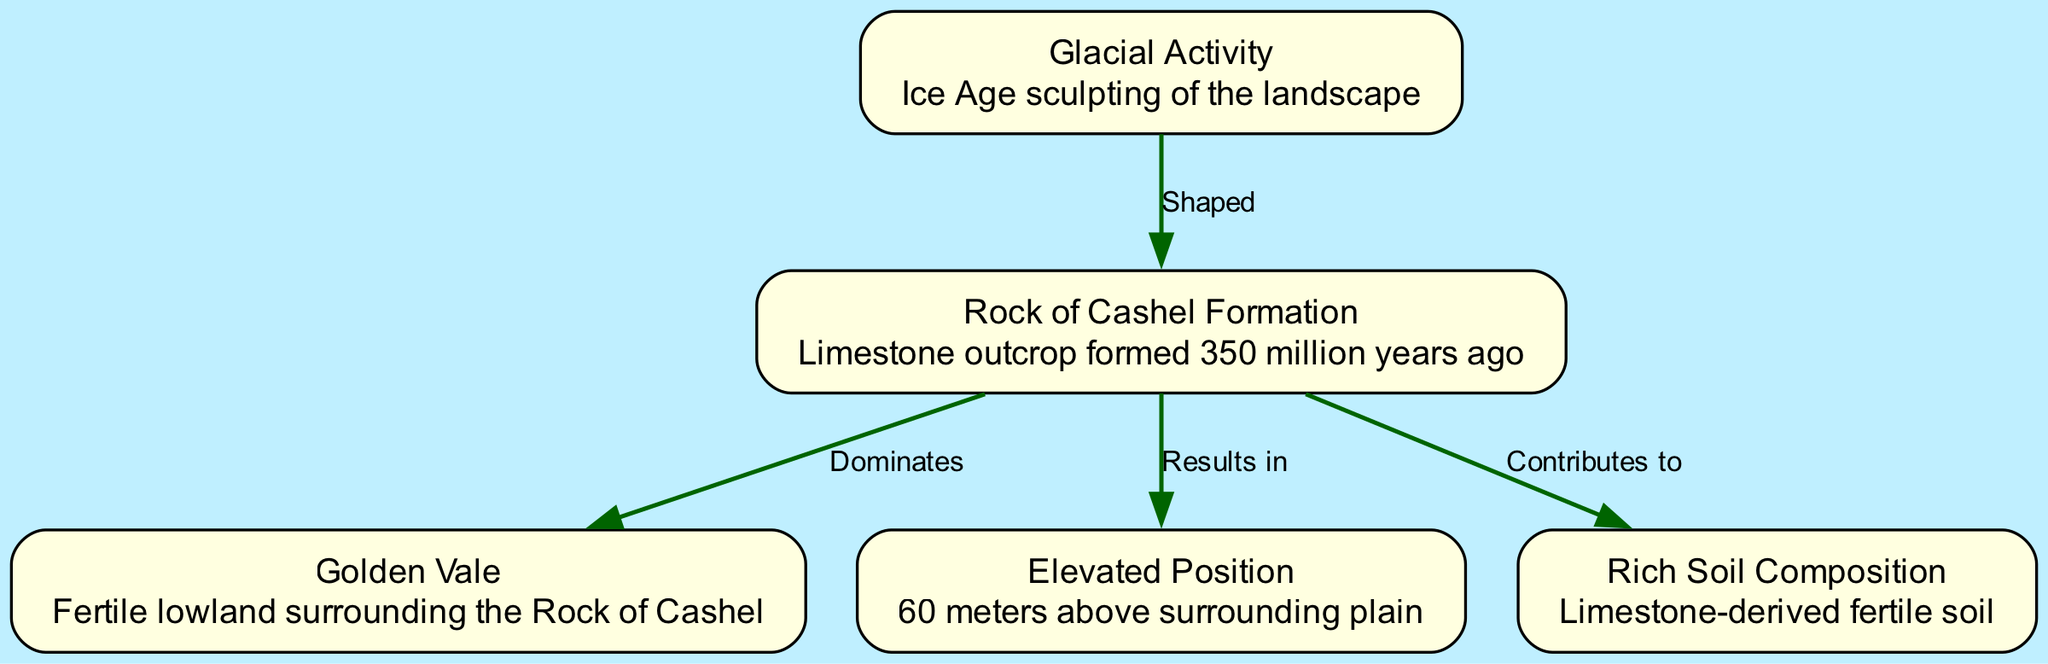What is the primary rock type at the Rock of Cashel? The diagram identifies the Rock of Cashel Formation as a limestone outcrop. This is found in the node description.
Answer: Limestone How many nodes are present in the diagram? The diagram includes five nodes, each representing a different element related to the geological formation of the Rock of Cashel.
Answer: 5 What is the height of the Rock of Cashel above the surrounding plain? The diagram specifies that the Rock of Cashel is 60 meters above the surrounding plain in the elevated position node.
Answer: 60 meters Which natural activity shaped the Rock of Cashel? According to the diagram, the glacial activity node indicates that glaciation was responsible for shaping the landscape where the Rock of Cashel is located.
Answer: Glaciation What does the Rock of Cashel contribute to in the surrounding area? The diagram's edge from the Rock of Cashel Formation to the soil node indicates that it contributes to the rich soil composition, as described in the node.
Answer: Rich Soil Composition What feature surrounds the Rock of Cashel? The diagram describes the Golden Vale as the fertile lowland that surrounds the Rock of Cashel, connecting it to the rock formation.
Answer: Golden Vale How does the Rock of Cashel affect the local terrain's elevation? The diagram indicates that the Rock of Cashel Formation results in an elevated position, specifically being 60 meters higher than the surrounding terrain, indicating its significant impact.
Answer: Elevated Position Which elements are connected by the edge labeled "Dominates"? The edge labeled "Dominates" connects the Rock of Cashel Formation to the Golden Vale, illustrating the influence of the formation over the surrounding fertile lowland.
Answer: Golden Vale What soil type results from the Rock of Cashel's formation? The diagram shows that the limestone-derived soil type is classified as fertile, demonstrating the contributions of the rock formation to the local soil quality.
Answer: Fertile Soil 